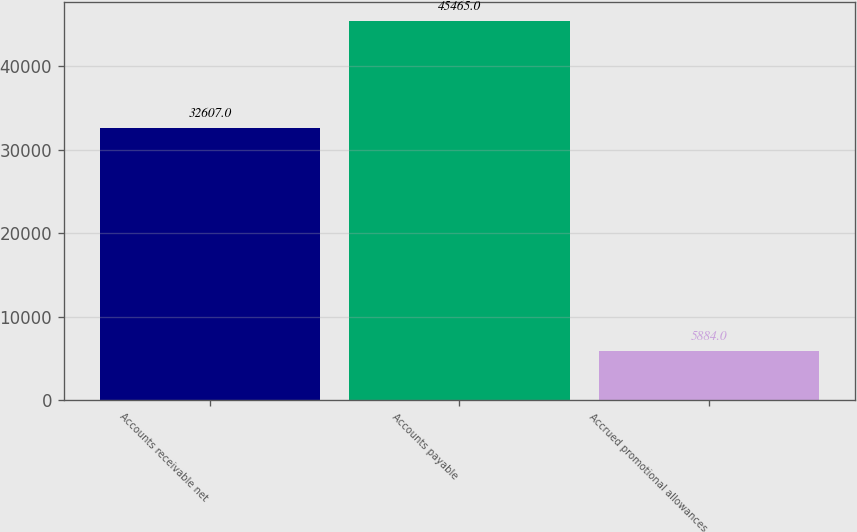Convert chart. <chart><loc_0><loc_0><loc_500><loc_500><bar_chart><fcel>Accounts receivable net<fcel>Accounts payable<fcel>Accrued promotional allowances<nl><fcel>32607<fcel>45465<fcel>5884<nl></chart> 